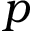<formula> <loc_0><loc_0><loc_500><loc_500>p</formula> 